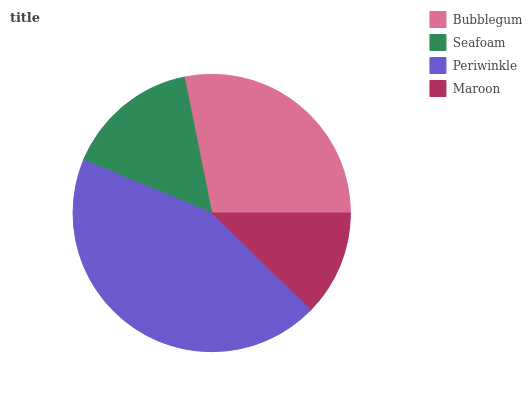Is Maroon the minimum?
Answer yes or no. Yes. Is Periwinkle the maximum?
Answer yes or no. Yes. Is Seafoam the minimum?
Answer yes or no. No. Is Seafoam the maximum?
Answer yes or no. No. Is Bubblegum greater than Seafoam?
Answer yes or no. Yes. Is Seafoam less than Bubblegum?
Answer yes or no. Yes. Is Seafoam greater than Bubblegum?
Answer yes or no. No. Is Bubblegum less than Seafoam?
Answer yes or no. No. Is Bubblegum the high median?
Answer yes or no. Yes. Is Seafoam the low median?
Answer yes or no. Yes. Is Seafoam the high median?
Answer yes or no. No. Is Periwinkle the low median?
Answer yes or no. No. 